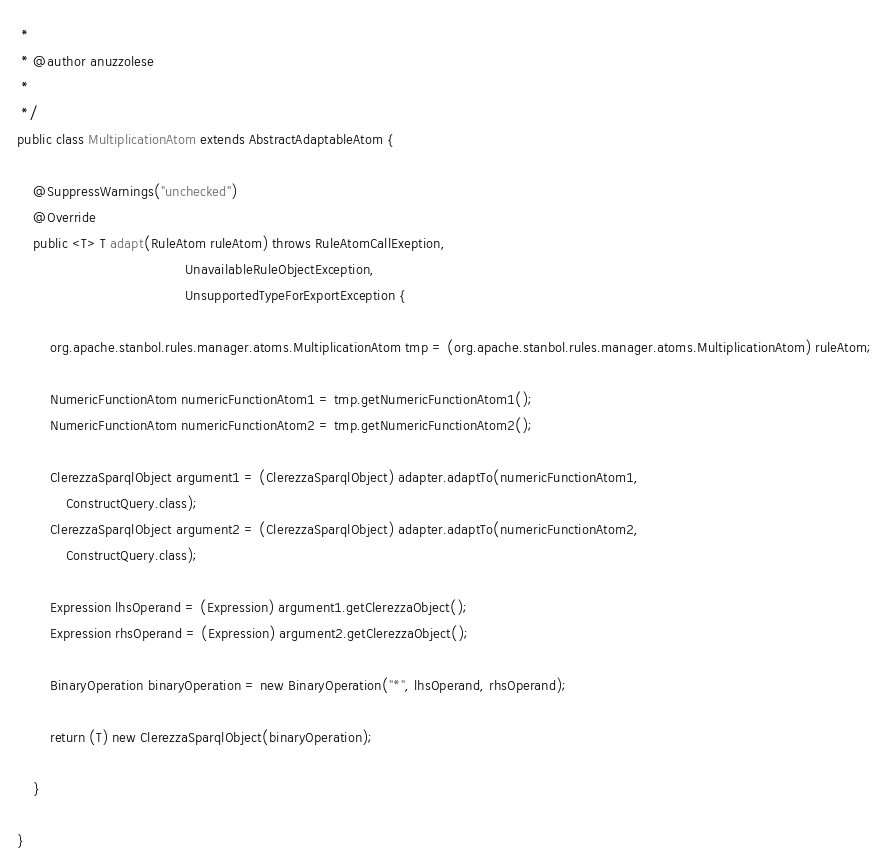Convert code to text. <code><loc_0><loc_0><loc_500><loc_500><_Java_> * 
 * @author anuzzolese
 * 
 */
public class MultiplicationAtom extends AbstractAdaptableAtom {

    @SuppressWarnings("unchecked")
    @Override
    public <T> T adapt(RuleAtom ruleAtom) throws RuleAtomCallExeption,
                                         UnavailableRuleObjectException,
                                         UnsupportedTypeForExportException {

        org.apache.stanbol.rules.manager.atoms.MultiplicationAtom tmp = (org.apache.stanbol.rules.manager.atoms.MultiplicationAtom) ruleAtom;

        NumericFunctionAtom numericFunctionAtom1 = tmp.getNumericFunctionAtom1();
        NumericFunctionAtom numericFunctionAtom2 = tmp.getNumericFunctionAtom2();

        ClerezzaSparqlObject argument1 = (ClerezzaSparqlObject) adapter.adaptTo(numericFunctionAtom1,
            ConstructQuery.class);
        ClerezzaSparqlObject argument2 = (ClerezzaSparqlObject) adapter.adaptTo(numericFunctionAtom2,
            ConstructQuery.class);

        Expression lhsOperand = (Expression) argument1.getClerezzaObject();
        Expression rhsOperand = (Expression) argument2.getClerezzaObject();

        BinaryOperation binaryOperation = new BinaryOperation("*", lhsOperand, rhsOperand);

        return (T) new ClerezzaSparqlObject(binaryOperation);

    }

}
</code> 